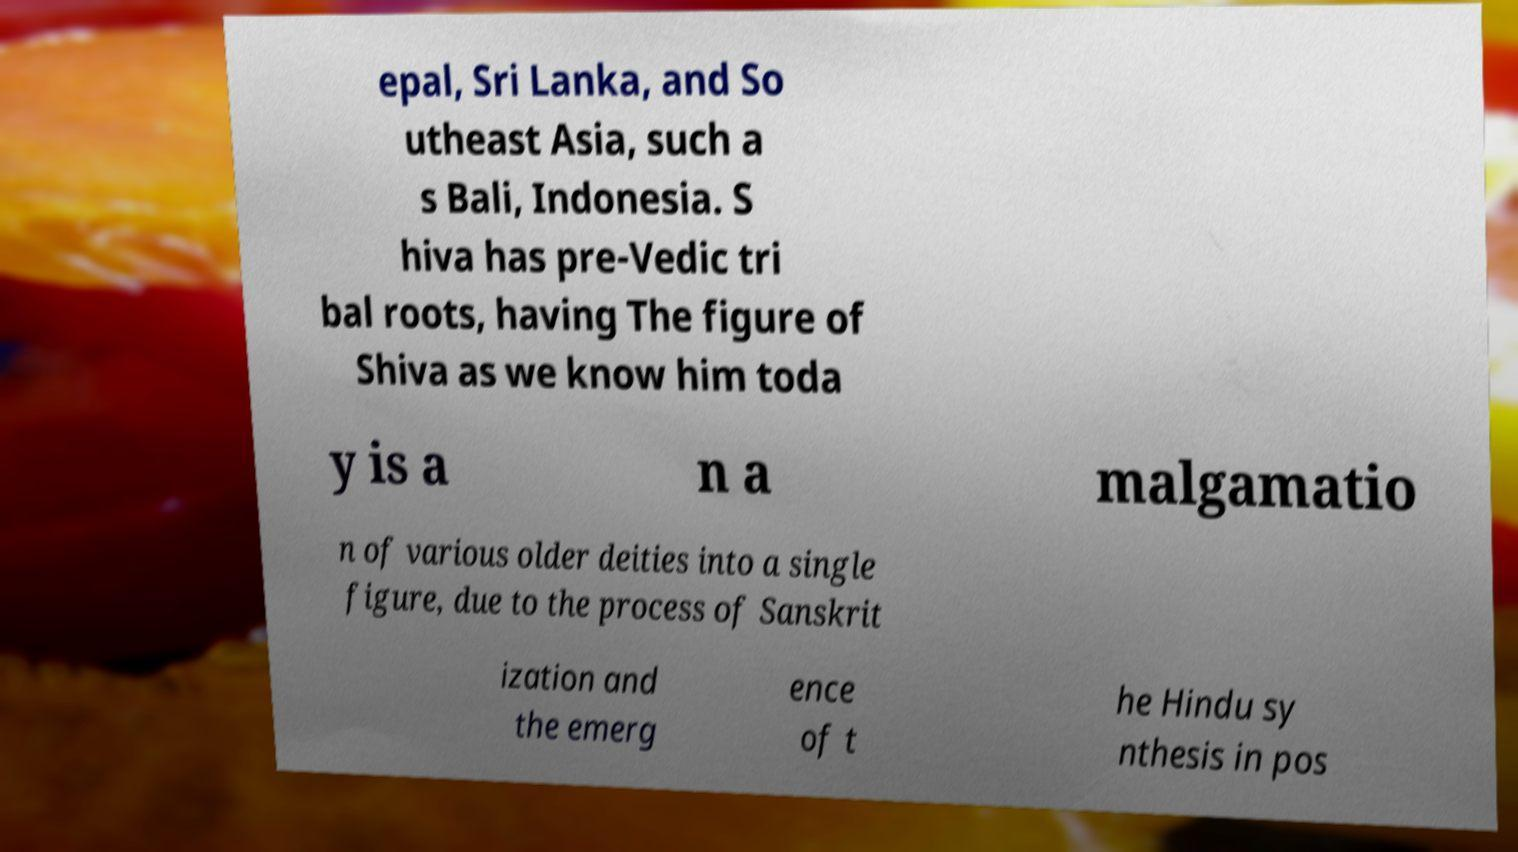There's text embedded in this image that I need extracted. Can you transcribe it verbatim? epal, Sri Lanka, and So utheast Asia, such a s Bali, Indonesia. S hiva has pre-Vedic tri bal roots, having The figure of Shiva as we know him toda y is a n a malgamatio n of various older deities into a single figure, due to the process of Sanskrit ization and the emerg ence of t he Hindu sy nthesis in pos 